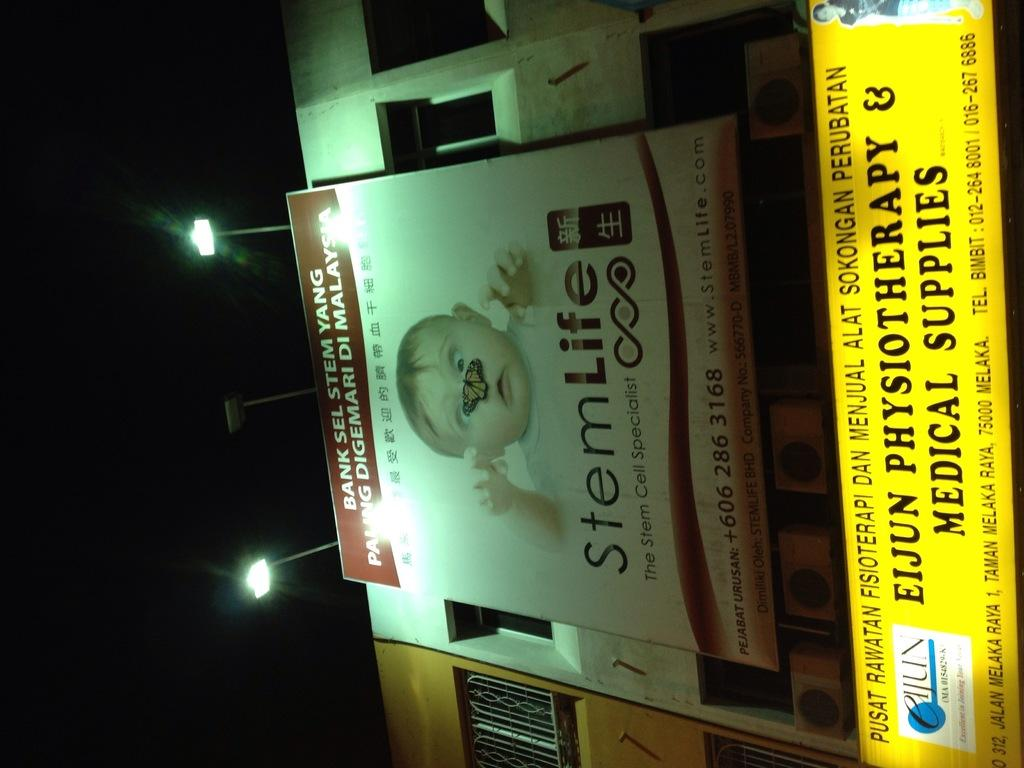<image>
Share a concise interpretation of the image provided. A stemlife billboard with a picture of a baby that has a butterfly on their nose. 